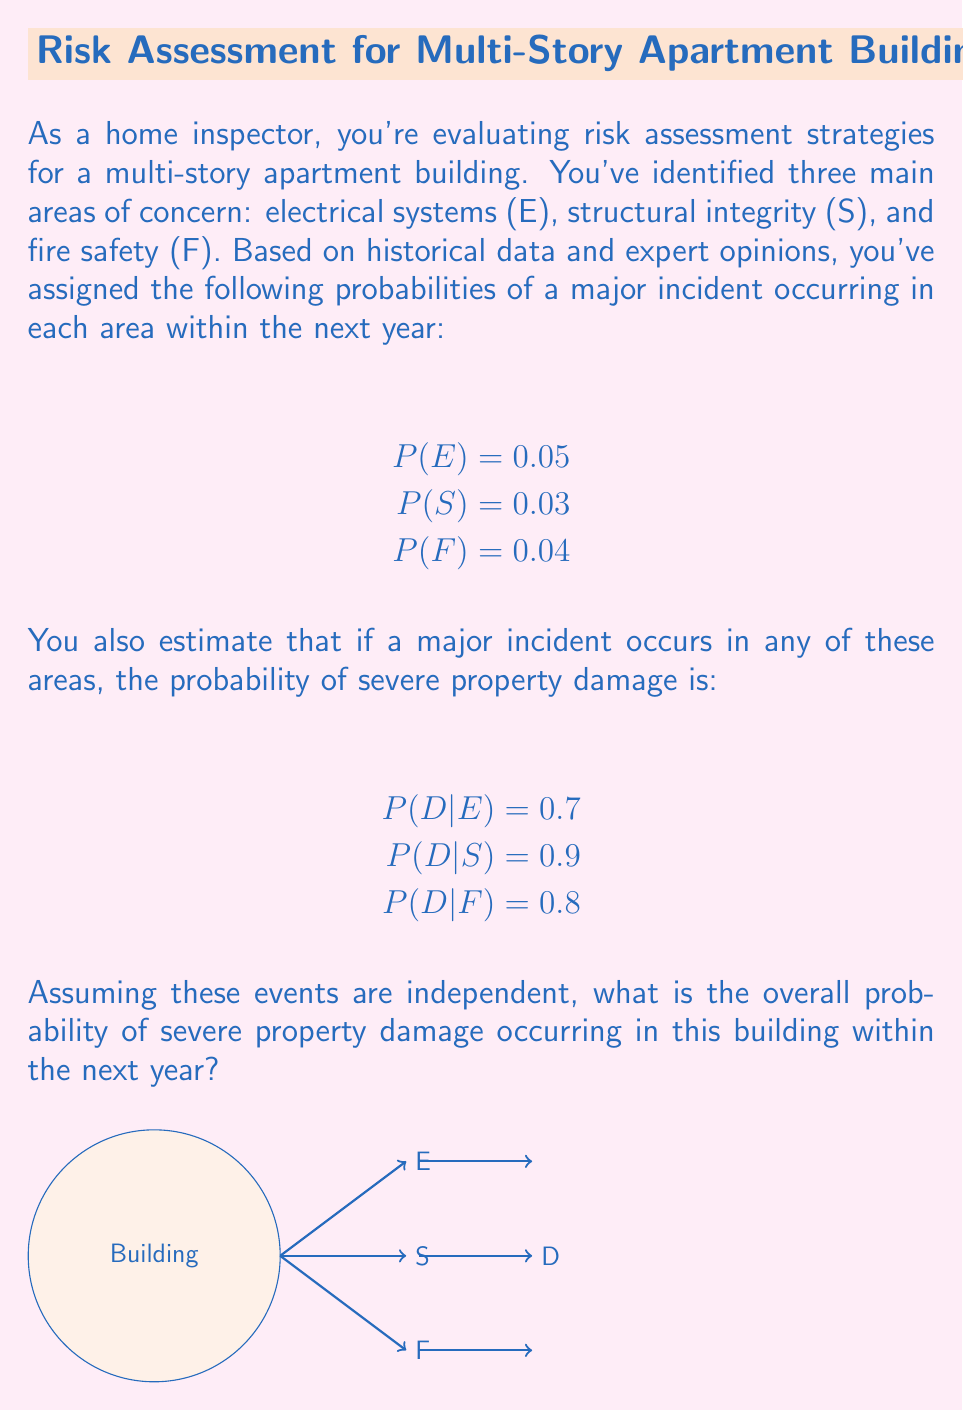Can you answer this question? To solve this problem, we'll use the law of total probability and the complement rule. Let's break it down step by step:

1) First, we need to calculate the probability of severe damage (D) occurring due to each type of incident:

   P(D and E) = P(E) * P(D|E) = 0.05 * 0.7 = 0.035
   P(D and S) = P(S) * P(D|S) = 0.03 * 0.9 = 0.027
   P(D and F) = P(F) * P(D|F) = 0.04 * 0.8 = 0.032

2) Now, we need to find the probability of severe damage occurring due to any of these incidents. However, we can't simply add these probabilities because that would double-count cases where multiple incidents occur.

3) Instead, it's easier to calculate the probability of no severe damage occurring, and then subtract that from 1. The probability of no severe damage is the product of the probabilities of no severe damage from each type of incident:

   P(No D) = (1 - P(D and E)) * (1 - P(D and S)) * (1 - P(D and F))
           = (1 - 0.035) * (1 - 0.027) * (1 - 0.032)
           = 0.965 * 0.973 * 0.968
           = 0.9085

4) Therefore, the probability of severe damage occurring is:

   P(D) = 1 - P(No D) = 1 - 0.9085 = 0.0915

5) We can convert this to a percentage: 0.0915 * 100 = 9.15%

Thus, the overall probability of severe property damage occurring in this building within the next year is approximately 9.15%.
Answer: 9.15% 